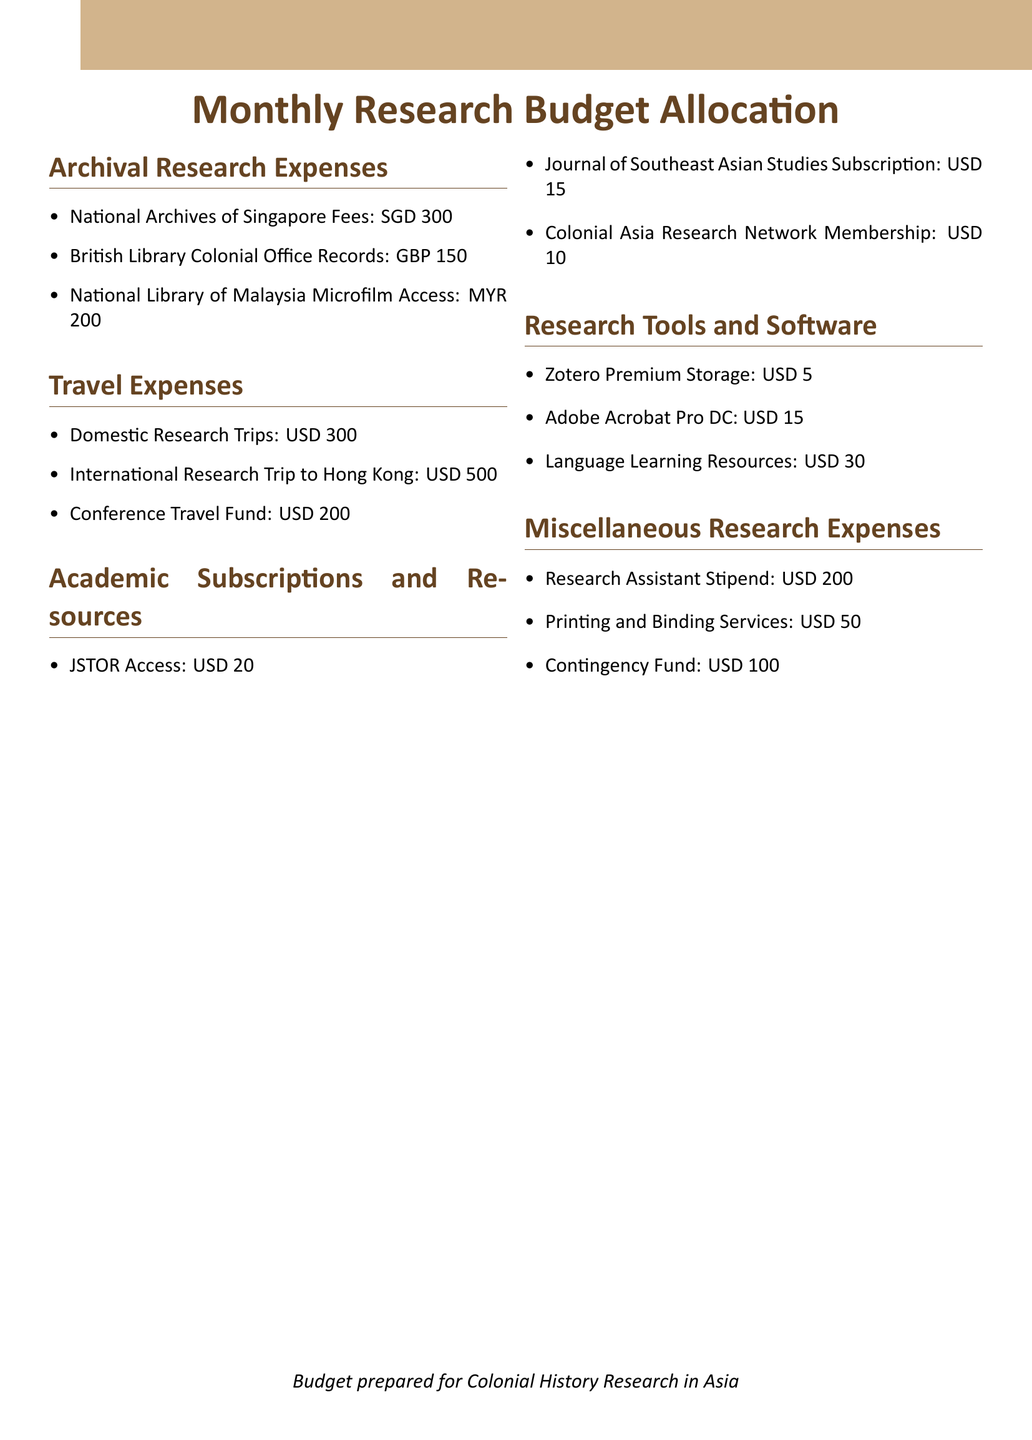What is the estimated cost for JSTOR Access? The estimated cost for JSTOR Access is mentioned as USD 20.
Answer: USD 20 How much is allocated for the National Archives of Singapore Fees? The document specifies a monthly allocation for the National Archives of Singapore Fees as SGD 300.
Answer: SGD 300 What is the budget for the International Research Trip to Hong Kong? The budget set aside for the International Research Trip to Hong Kong is USD 500.
Answer: USD 500 What is the total estimated cost for Research Tools and Software? The total estimated cost for Research Tools and Software is calculated by adding all items listed under this section: USD 5 + USD 15 + USD 30 = USD 50.
Answer: USD 50 How much is allocated per month for the Research Assistant Stipend? The document shows a monthly allocation for the Research Assistant Stipend as USD 200.
Answer: USD 200 What type of document is being discussed? The document outlines budget allocations for specific research expenses.
Answer: Monthly Research Budget Allocation What is the total estimated cost for Travel Expenses? The total estimated cost for Travel Expenses is the sum of all items listed under this section: USD 300 + USD 500 + USD 200 = USD 1000.
Answer: USD 1000 Which section contains the cost for the Colonial Asia Research Network Membership? The cost for the Colonial Asia Research Network Membership is located in the Academic Subscriptions and Resources section.
Answer: Academic Subscriptions and Resources What is included in the Miscellaneous Research Expenses category? The category includes Research Assistant Stipend, Printing and Binding Services, and Contingency Fund.
Answer: Research Assistant Stipend, Printing and Binding Services, Contingency Fund 